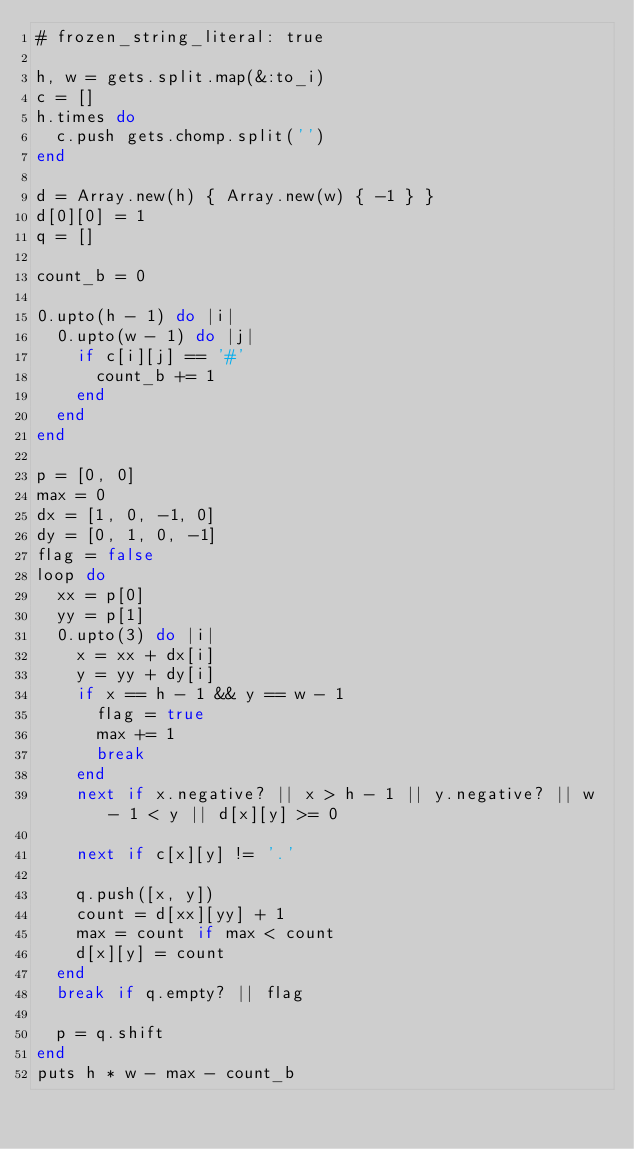Convert code to text. <code><loc_0><loc_0><loc_500><loc_500><_Ruby_># frozen_string_literal: true

h, w = gets.split.map(&:to_i)
c = []
h.times do
  c.push gets.chomp.split('')
end

d = Array.new(h) { Array.new(w) { -1 } }
d[0][0] = 1
q = []

count_b = 0

0.upto(h - 1) do |i|
  0.upto(w - 1) do |j|
    if c[i][j] == '#'
      count_b += 1
    end
  end
end

p = [0, 0]
max = 0
dx = [1, 0, -1, 0]
dy = [0, 1, 0, -1]
flag = false
loop do
  xx = p[0]
  yy = p[1]
  0.upto(3) do |i|
    x = xx + dx[i]
    y = yy + dy[i]
    if x == h - 1 && y == w - 1
      flag = true
      max += 1
      break
    end
    next if x.negative? || x > h - 1 || y.negative? || w - 1 < y || d[x][y] >= 0

    next if c[x][y] != '.'

    q.push([x, y])
    count = d[xx][yy] + 1
    max = count if max < count
    d[x][y] = count
  end
  break if q.empty? || flag

  p = q.shift
end
puts h * w - max - count_b
</code> 